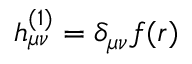<formula> <loc_0><loc_0><loc_500><loc_500>h _ { \mu \nu } ^ { ( 1 ) } = \delta _ { \mu \nu } f ( r )</formula> 